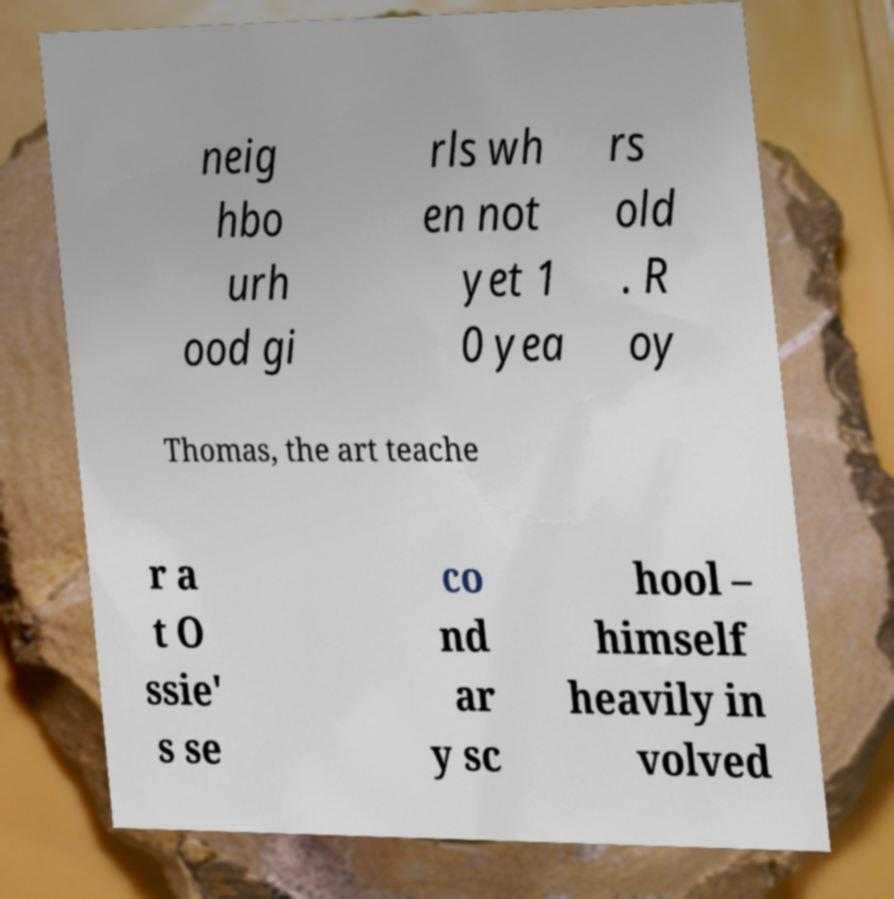What messages or text are displayed in this image? I need them in a readable, typed format. neig hbo urh ood gi rls wh en not yet 1 0 yea rs old . R oy Thomas, the art teache r a t O ssie' s se co nd ar y sc hool – himself heavily in volved 